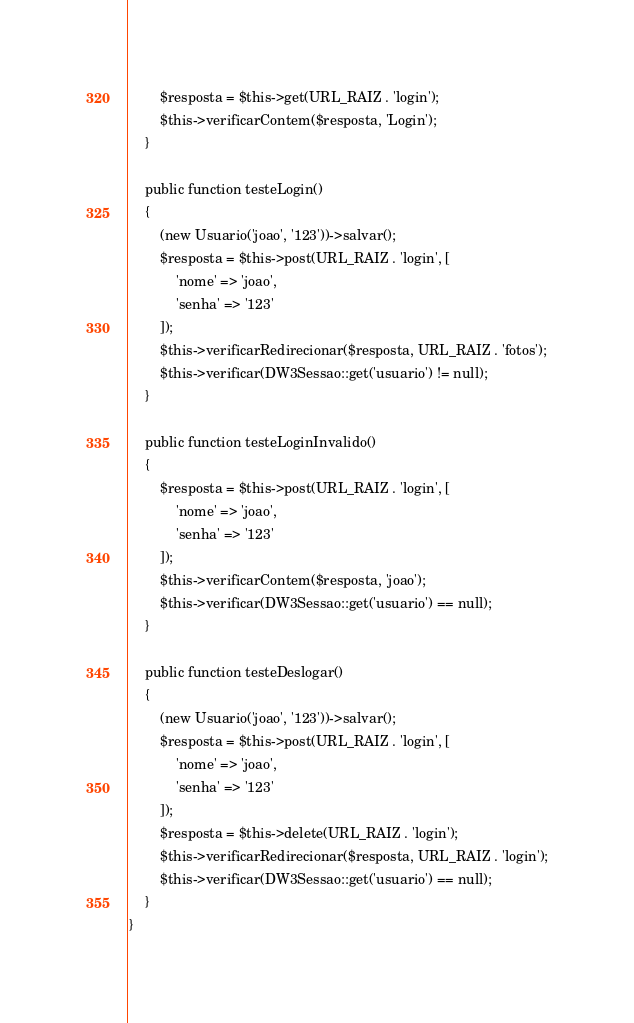Convert code to text. <code><loc_0><loc_0><loc_500><loc_500><_PHP_>        $resposta = $this->get(URL_RAIZ . 'login');
        $this->verificarContem($resposta, 'Login');
    }

    public function testeLogin()
    {
        (new Usuario('joao', '123'))->salvar();
        $resposta = $this->post(URL_RAIZ . 'login', [
            'nome' => 'joao',
            'senha' => '123'
        ]);
        $this->verificarRedirecionar($resposta, URL_RAIZ . 'fotos');
        $this->verificar(DW3Sessao::get('usuario') != null);
    }

    public function testeLoginInvalido()
    {
        $resposta = $this->post(URL_RAIZ . 'login', [
            'nome' => 'joao',
            'senha' => '123'
        ]);
        $this->verificarContem($resposta, 'joao');
        $this->verificar(DW3Sessao::get('usuario') == null);
    }

    public function testeDeslogar()
    {
        (new Usuario('joao', '123'))->salvar();
        $resposta = $this->post(URL_RAIZ . 'login', [
            'nome' => 'joao',
            'senha' => '123'
        ]);
        $resposta = $this->delete(URL_RAIZ . 'login');
        $this->verificarRedirecionar($resposta, URL_RAIZ . 'login');
        $this->verificar(DW3Sessao::get('usuario') == null);
    }
}
</code> 